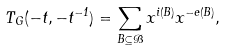<formula> <loc_0><loc_0><loc_500><loc_500>T _ { G } ( - t , - t ^ { - 1 } ) = \sum _ { B \subseteq \mathcal { B } } x ^ { i ( B ) } x ^ { - e ( B ) } ,</formula> 